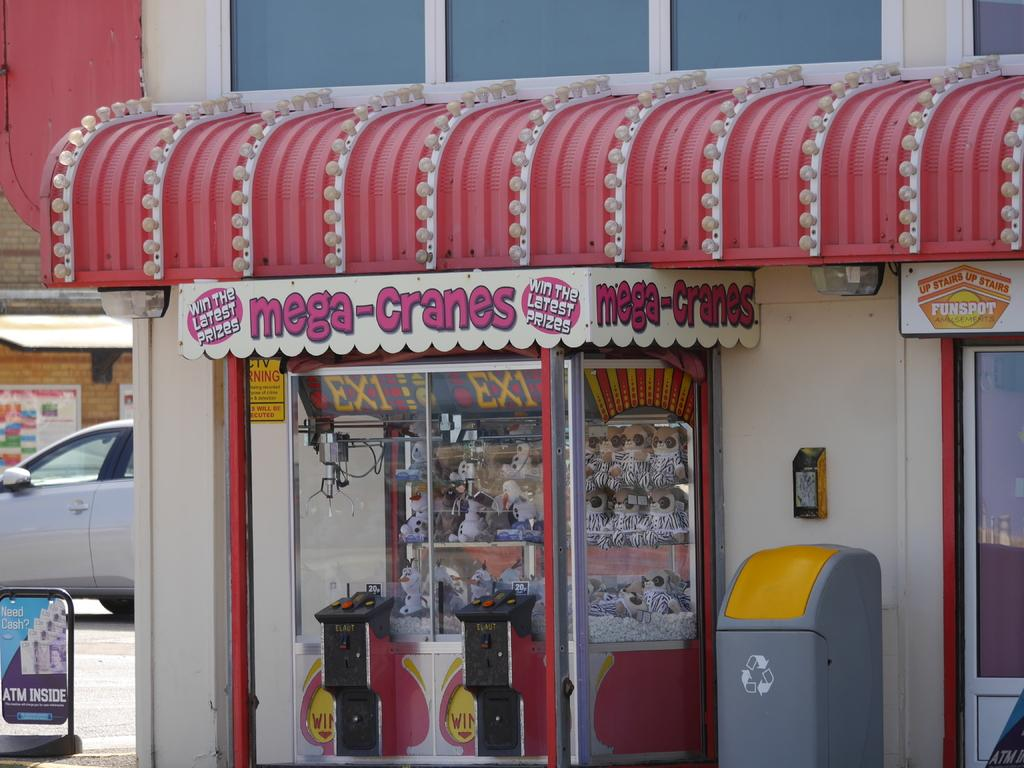What object can be seen in the image for disposing of waste? There is a dustbin in the image. What type of structure is present with boards in the image? There is a building with boards in the image. Can you describe the board visible to the left of the image? There is a board visible to the left of the image. What is moving along the road in the image? There is a vehicle on the road in the image. Are there any other structures with boards in the image? Yes, there is another building with boards in the image. What is the texture of the cellar in the image? There is no cellar present in the image. How does the increase in board usage affect the overall aesthetic of the image? The image does not provide information about the overall aesthetic or the impact of board usage. 